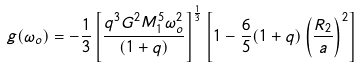<formula> <loc_0><loc_0><loc_500><loc_500>g ( \omega _ { o } ) = - \frac { 1 } { 3 } \left [ \frac { q ^ { 3 } G ^ { 2 } M ^ { 5 } _ { 1 } \omega ^ { 2 } _ { o } } { ( 1 + q ) } \right ] ^ { \frac { 1 } { 3 } } \left [ 1 - \frac { 6 } { 5 } ( 1 + q ) \left ( \frac { R _ { 2 } } { a } \right ) ^ { 2 } \right ]</formula> 